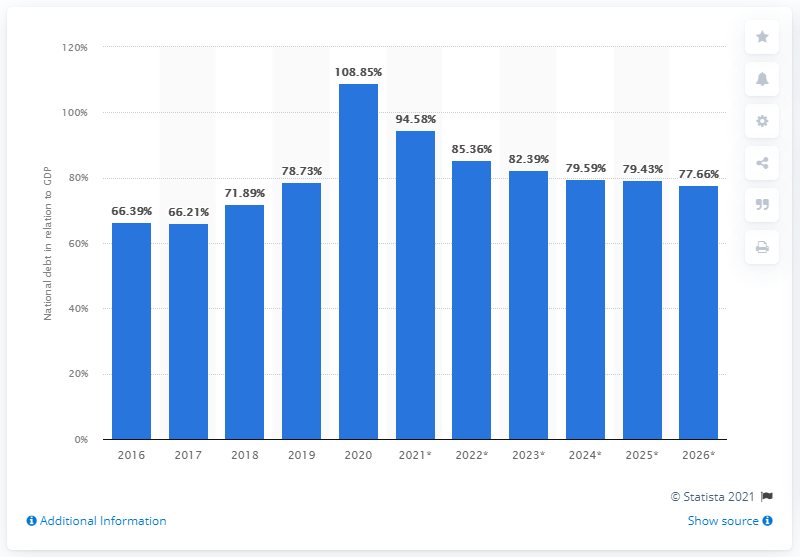Point out several critical features in this image. In 2020, Montenegro's national debt came to an end. In 2020, Montenegro's national debt represented 31.2% of the country's GDP. 